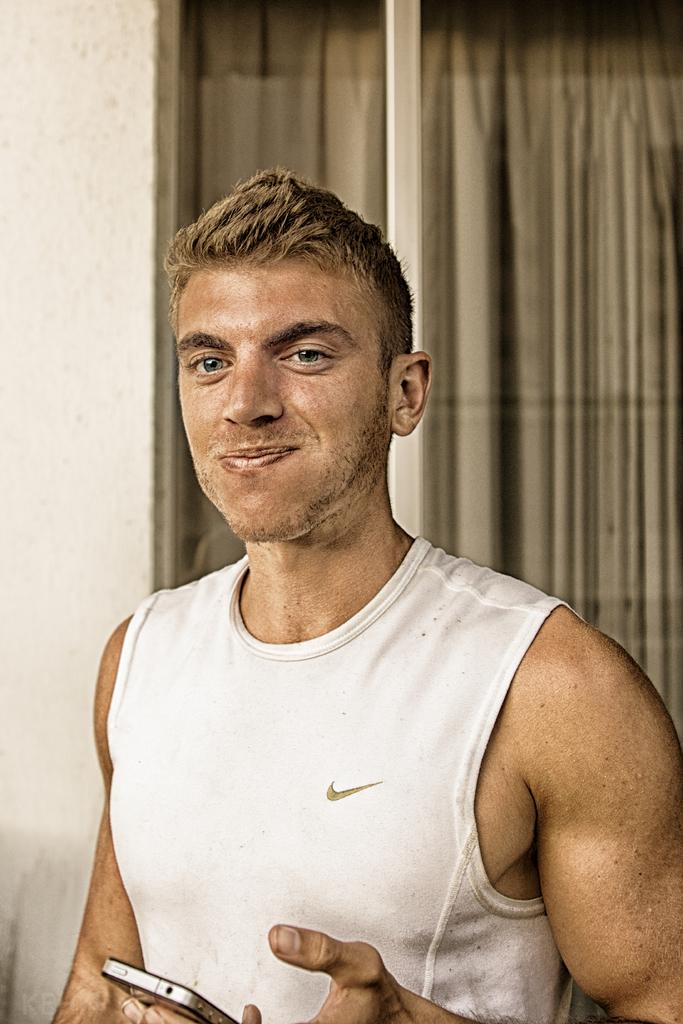What is the setting of the image? The image is of a room. Is there anyone present in the room? Yes, there is a person standing in the room. What is the person holding in the image? The person is holding a phone. What type of window treatment is present in the room? There is a curtain in the room. What is a prominent feature of the room's structure? There is a wall in the room. What type of songs can be heard playing in the background of the image? There is no audio or indication of music in the image, so it is not possible to determine what songs might be playing. 